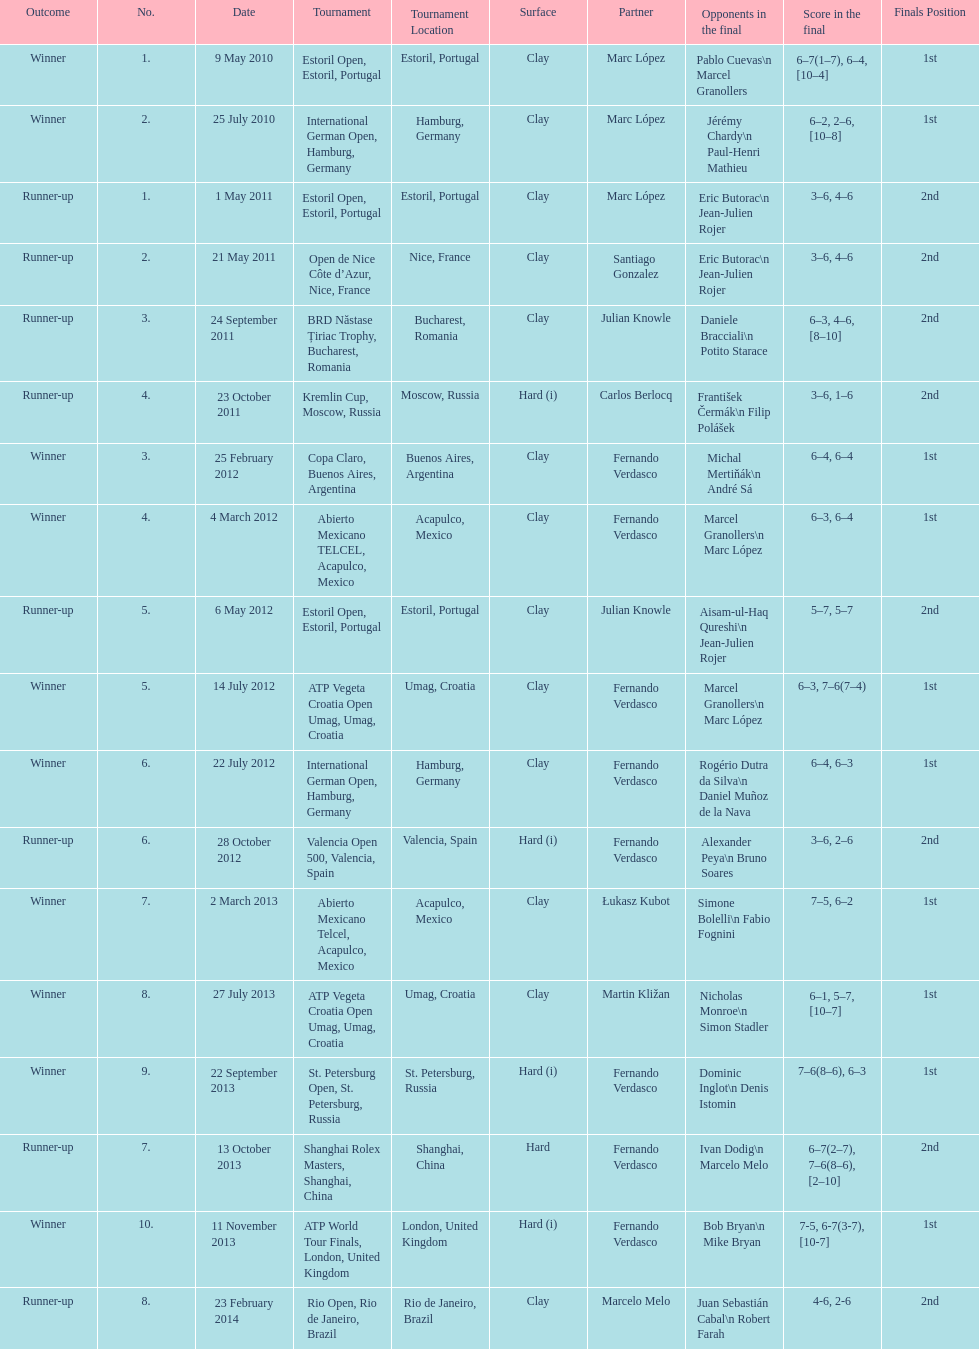Who was this player's next partner after playing with marc lopez in may 2011? Santiago Gonzalez. 